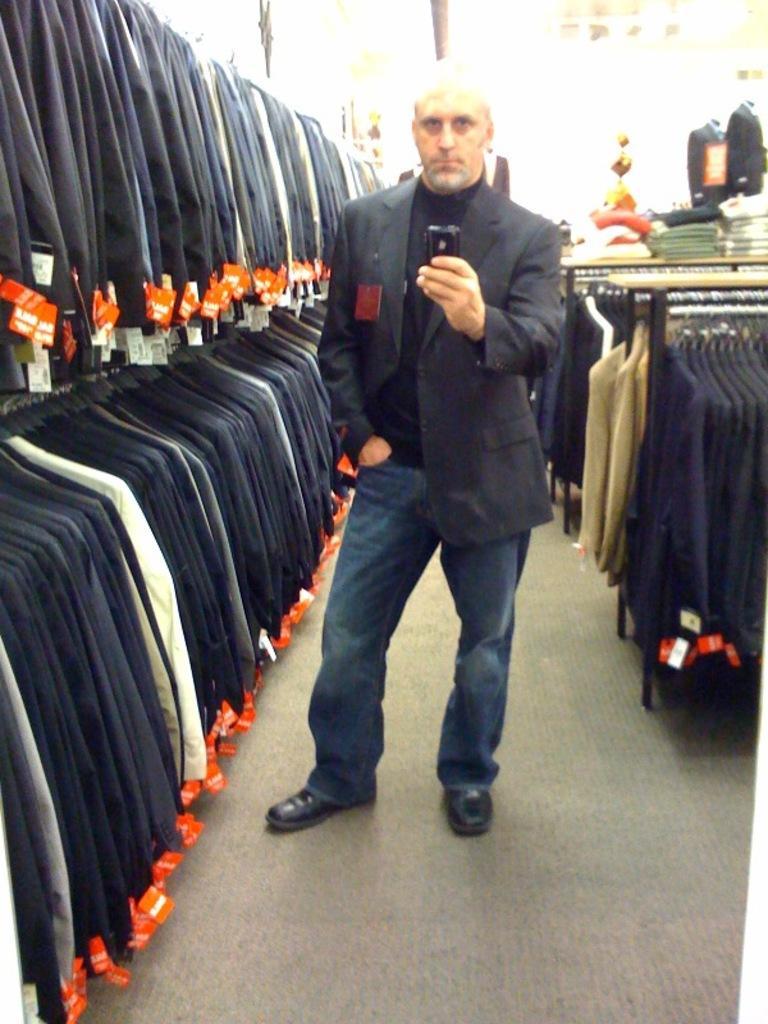Could you give a brief overview of what you see in this image? In the center of the image we can see a man is standing and wearing suit and holding a mobile. In the background of the image we can see the clothes, tags on the clothes are hanging to the hangers. On the right side of the image we can see the mannequins. At the bottom of the image we can see the floor. 